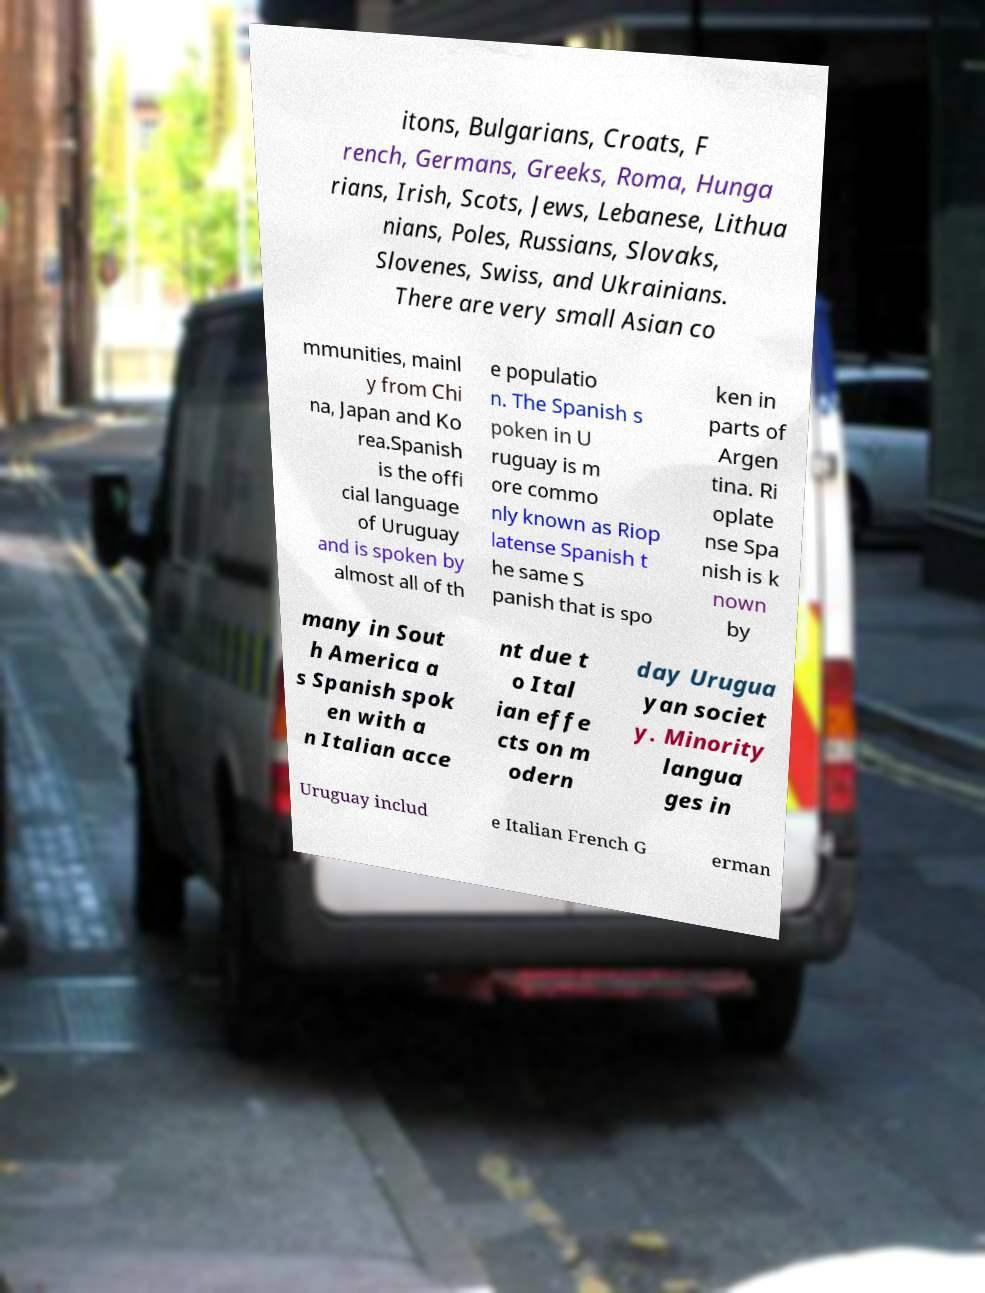For documentation purposes, I need the text within this image transcribed. Could you provide that? itons, Bulgarians, Croats, F rench, Germans, Greeks, Roma, Hunga rians, Irish, Scots, Jews, Lebanese, Lithua nians, Poles, Russians, Slovaks, Slovenes, Swiss, and Ukrainians. There are very small Asian co mmunities, mainl y from Chi na, Japan and Ko rea.Spanish is the offi cial language of Uruguay and is spoken by almost all of th e populatio n. The Spanish s poken in U ruguay is m ore commo nly known as Riop latense Spanish t he same S panish that is spo ken in parts of Argen tina. Ri oplate nse Spa nish is k nown by many in Sout h America a s Spanish spok en with a n Italian acce nt due t o Ital ian effe cts on m odern day Urugua yan societ y. Minority langua ges in Uruguay includ e Italian French G erman 